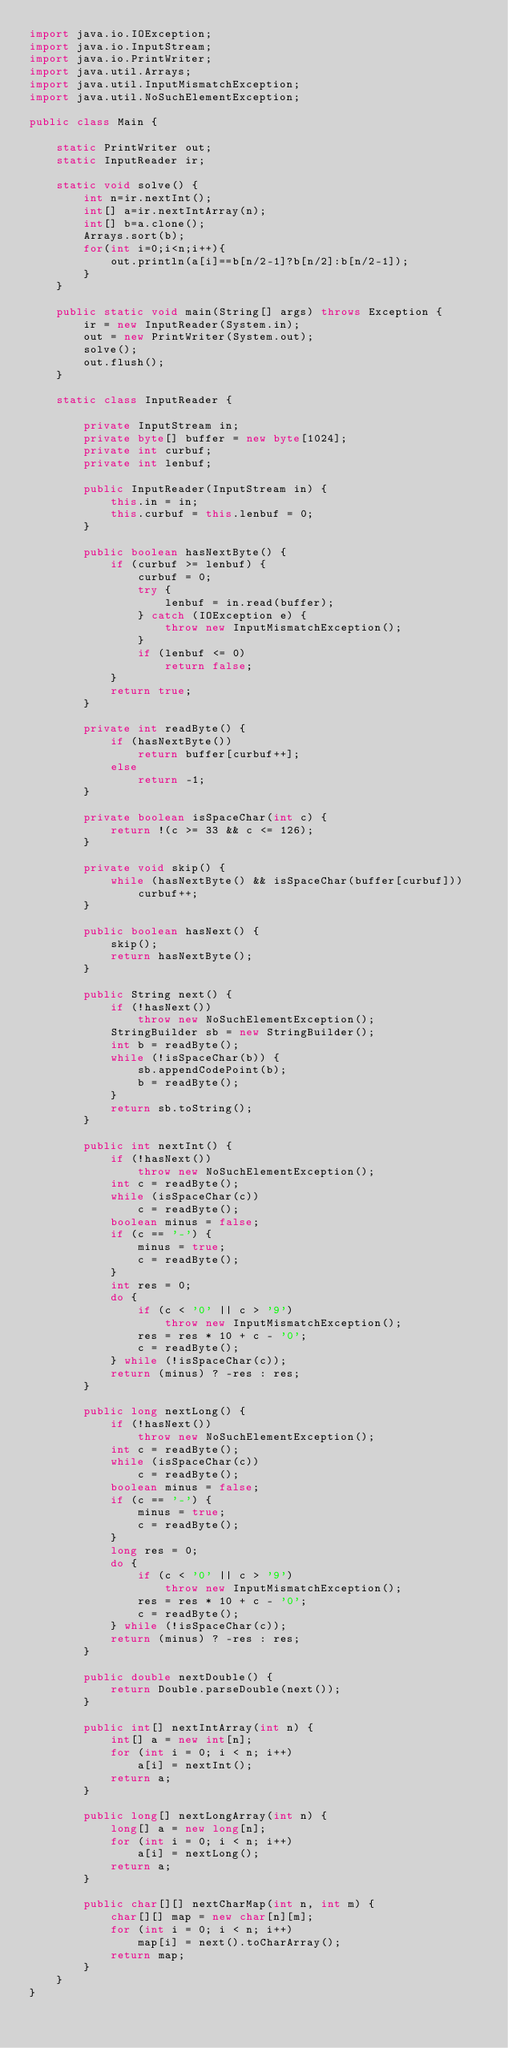<code> <loc_0><loc_0><loc_500><loc_500><_Java_>import java.io.IOException;
import java.io.InputStream;
import java.io.PrintWriter;
import java.util.Arrays;
import java.util.InputMismatchException;
import java.util.NoSuchElementException;

public class Main {

	static PrintWriter out;
	static InputReader ir;

	static void solve() {
		int n=ir.nextInt();
		int[] a=ir.nextIntArray(n);
		int[] b=a.clone();
		Arrays.sort(b);
		for(int i=0;i<n;i++){
			out.println(a[i]==b[n/2-1]?b[n/2]:b[n/2-1]);
		}
	}

	public static void main(String[] args) throws Exception {
		ir = new InputReader(System.in);
		out = new PrintWriter(System.out);
		solve();
		out.flush();
	}

	static class InputReader {

		private InputStream in;
		private byte[] buffer = new byte[1024];
		private int curbuf;
		private int lenbuf;

		public InputReader(InputStream in) {
			this.in = in;
			this.curbuf = this.lenbuf = 0;
		}

		public boolean hasNextByte() {
			if (curbuf >= lenbuf) {
				curbuf = 0;
				try {
					lenbuf = in.read(buffer);
				} catch (IOException e) {
					throw new InputMismatchException();
				}
				if (lenbuf <= 0)
					return false;
			}
			return true;
		}

		private int readByte() {
			if (hasNextByte())
				return buffer[curbuf++];
			else
				return -1;
		}

		private boolean isSpaceChar(int c) {
			return !(c >= 33 && c <= 126);
		}

		private void skip() {
			while (hasNextByte() && isSpaceChar(buffer[curbuf]))
				curbuf++;
		}

		public boolean hasNext() {
			skip();
			return hasNextByte();
		}

		public String next() {
			if (!hasNext())
				throw new NoSuchElementException();
			StringBuilder sb = new StringBuilder();
			int b = readByte();
			while (!isSpaceChar(b)) {
				sb.appendCodePoint(b);
				b = readByte();
			}
			return sb.toString();
		}

		public int nextInt() {
			if (!hasNext())
				throw new NoSuchElementException();
			int c = readByte();
			while (isSpaceChar(c))
				c = readByte();
			boolean minus = false;
			if (c == '-') {
				minus = true;
				c = readByte();
			}
			int res = 0;
			do {
				if (c < '0' || c > '9')
					throw new InputMismatchException();
				res = res * 10 + c - '0';
				c = readByte();
			} while (!isSpaceChar(c));
			return (minus) ? -res : res;
		}

		public long nextLong() {
			if (!hasNext())
				throw new NoSuchElementException();
			int c = readByte();
			while (isSpaceChar(c))
				c = readByte();
			boolean minus = false;
			if (c == '-') {
				minus = true;
				c = readByte();
			}
			long res = 0;
			do {
				if (c < '0' || c > '9')
					throw new InputMismatchException();
				res = res * 10 + c - '0';
				c = readByte();
			} while (!isSpaceChar(c));
			return (minus) ? -res : res;
		}

		public double nextDouble() {
			return Double.parseDouble(next());
		}

		public int[] nextIntArray(int n) {
			int[] a = new int[n];
			for (int i = 0; i < n; i++)
				a[i] = nextInt();
			return a;
		}

		public long[] nextLongArray(int n) {
			long[] a = new long[n];
			for (int i = 0; i < n; i++)
				a[i] = nextLong();
			return a;
		}

		public char[][] nextCharMap(int n, int m) {
			char[][] map = new char[n][m];
			for (int i = 0; i < n; i++)
				map[i] = next().toCharArray();
			return map;
		}
	}
}
</code> 